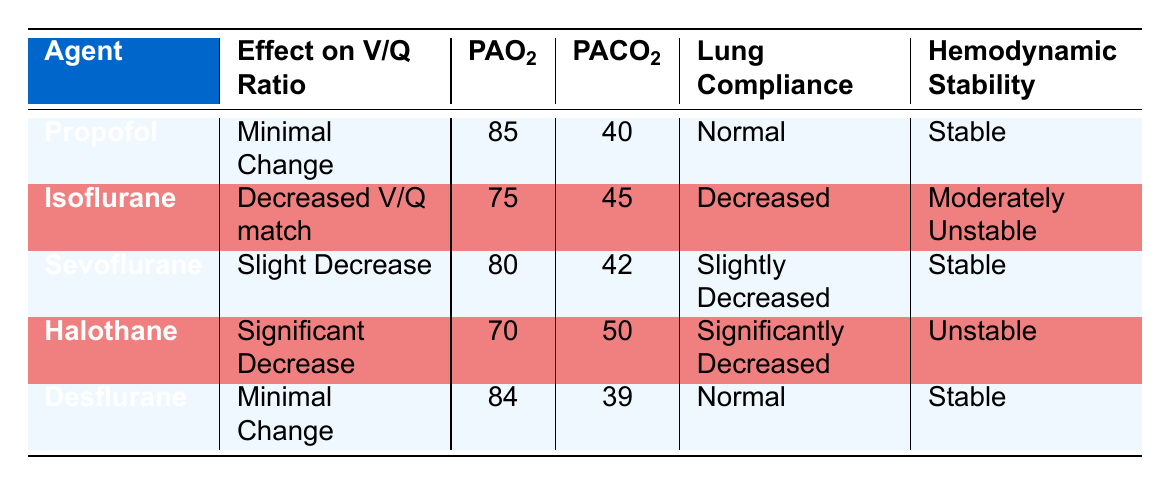What effect on the V/Q ratio does Halothane have? Referring to the table, Halothane has a "Significant Decrease" effect on the V/Q ratio.
Answer: Significant Decrease Which anesthetic agent has the highest PAO2 value? From the table, Propofol has the highest PAO2 value at 85.
Answer: 85 Is Isoflurane associated with stable hemodynamic stability? The table indicates that Isoflurane is "Moderately Unstable," which means it is not associated with stable hemodynamic stability.
Answer: No What is the average PACO2 level of the anesthetic agents listed? The PACO2 values are 40, 45, 42, 50, and 39. Summing these gives 216, and dividing by 5 gives an average PACO2 of 43.2.
Answer: 43.2 Does Desflurane show any changes in lung compliance? According to the table, Desflurane has "Normal" lung compliance, indicating no changes.
Answer: No changes How many anesthetic agents exhibit a minimal change in V/Q ratio? From the table, Propofol and Desflurane both show a "Minimal Change" in the V/Q ratio, making a total of 2 agents.
Answer: 2 What is the difference in PAO2 between Halothane and Sevoflurane? The PAO2 for Halothane is 70, and for Sevoflurane, it is 80. The difference is 80 - 70 = 10.
Answer: 10 Identify one anesthetic agent that shows decreased lung compliance. The table shows Isoflurane with "Decreased" lung compliance.
Answer: Isoflurane What is the hemodynamic stability for agents with a slight decrease in V/Q ratio? Sevoflurane, which has a "Slight Decrease" in V/Q ratio, is listed as "Stable" for hemodynamic stability.
Answer: Stable 